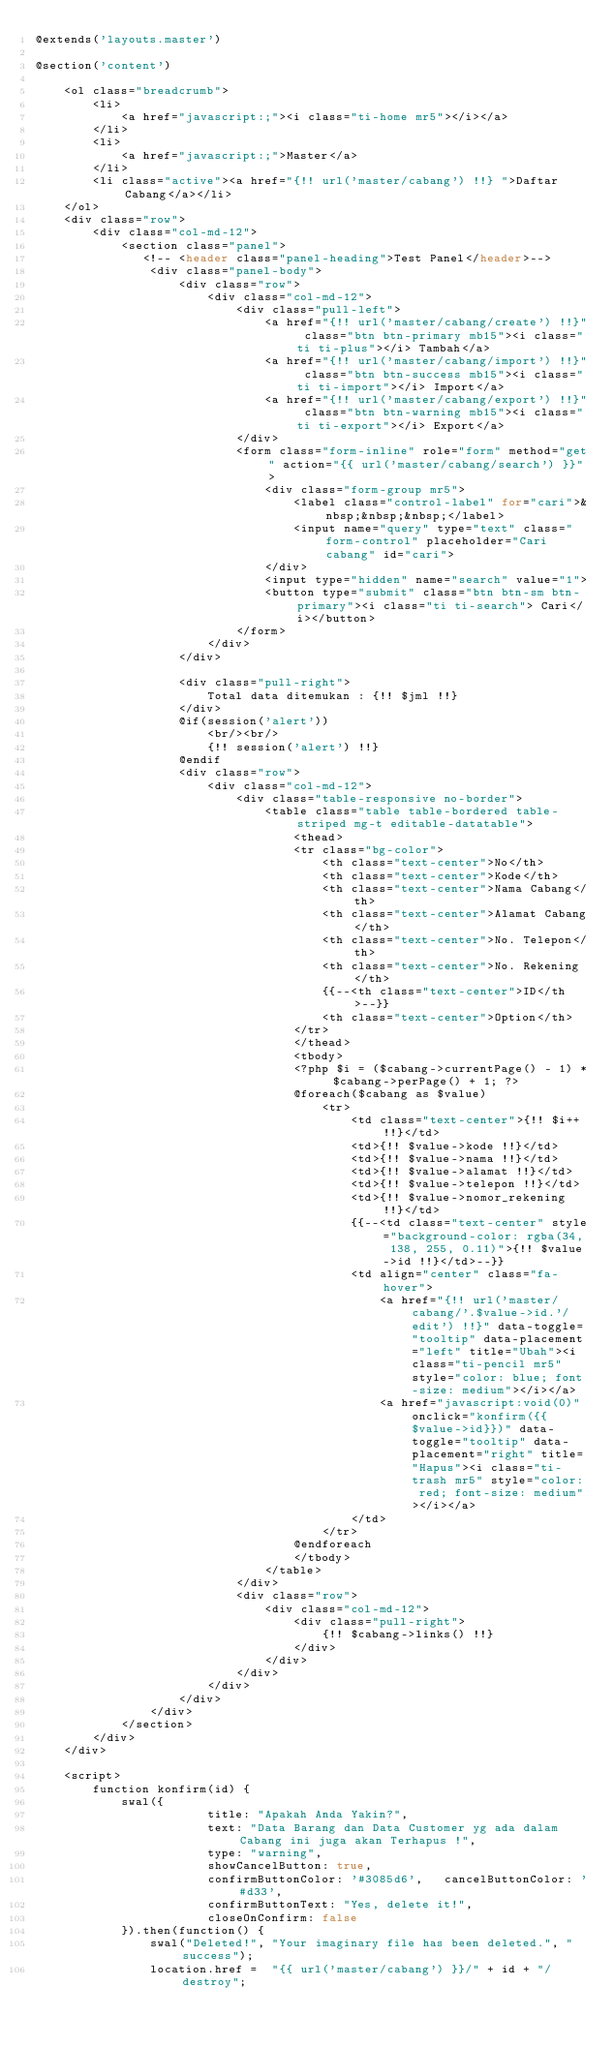Convert code to text. <code><loc_0><loc_0><loc_500><loc_500><_PHP_>@extends('layouts.master')

@section('content')

    <ol class="breadcrumb">
        <li>
            <a href="javascript:;"><i class="ti-home mr5"></i></a>
        </li>
        <li>
            <a href="javascript:;">Master</a>
        </li>
        <li class="active"><a href="{!! url('master/cabang') !!} ">Daftar Cabang</a></li>
    </ol>
    <div class="row">
        <div class="col-md-12">
            <section class="panel">
               <!-- <header class="panel-heading">Test Panel</header>-->
                <div class="panel-body">
                    <div class="row">
                        <div class="col-md-12">
                            <div class="pull-left">
                                <a href="{!! url('master/cabang/create') !!}" class="btn btn-primary mb15"><i class="ti ti-plus"></i> Tambah</a>
                                <a href="{!! url('master/cabang/import') !!}" class="btn btn-success mb15"><i class="ti ti-import"></i> Import</a>
                                <a href="{!! url('master/cabang/export') !!}" class="btn btn-warning mb15"><i class="ti ti-export"></i> Export</a>
                            </div>
                            <form class="form-inline" role="form" method="get" action="{{ url('master/cabang/search') }}">
                                <div class="form-group mr5">
                                    <label class="control-label" for="cari">&nbsp;&nbsp;&nbsp;</label>
                                    <input name="query" type="text" class="form-control" placeholder="Cari cabang" id="cari">
                                </div>
                                <input type="hidden" name="search" value="1">
                                <button type="submit" class="btn btn-sm btn-primary"><i class="ti ti-search"> Cari</i></button>
                            </form>
                        </div>
                    </div>

                    <div class="pull-right">
                        Total data ditemukan : {!! $jml !!}
                    </div>
                    @if(session('alert'))
                        <br/><br/>
                        {!! session('alert') !!}
                    @endif
                    <div class="row">
                        <div class="col-md-12">
                            <div class="table-responsive no-border">
                                <table class="table table-bordered table-striped mg-t editable-datatable">
                                    <thead>
                                    <tr class="bg-color">
                                        <th class="text-center">No</th>
                                        <th class="text-center">Kode</th>
                                        <th class="text-center">Nama Cabang</th>
                                        <th class="text-center">Alamat Cabang</th>
                                        <th class="text-center">No. Telepon</th>
                                        <th class="text-center">No. Rekening</th>
                                        {{--<th class="text-center">ID</th>--}}
                                        <th class="text-center">Option</th>
                                    </tr>
                                    </thead>
                                    <tbody>
                                    <?php $i = ($cabang->currentPage() - 1) * $cabang->perPage() + 1; ?>
                                    @foreach($cabang as $value)
                                        <tr>
                                            <td class="text-center">{!! $i++ !!}</td>
                                            <td>{!! $value->kode !!}</td>
                                            <td>{!! $value->nama !!}</td>
                                            <td>{!! $value->alamat !!}</td>
                                            <td>{!! $value->telepon !!}</td>
                                            <td>{!! $value->nomor_rekening !!}</td>
                                            {{--<td class="text-center" style="background-color: rgba(34, 138, 255, 0.11)">{!! $value->id !!}</td>--}}
                                            <td align="center" class="fa-hover">
                                                <a href="{!! url('master/cabang/'.$value->id.'/edit') !!}" data-toggle="tooltip" data-placement="left" title="Ubah"><i class="ti-pencil mr5" style="color: blue; font-size: medium"></i></a>
                                                <a href="javascript:void(0)" onclick="konfirm({{$value->id}})" data-toggle="tooltip" data-placement="right" title="Hapus"><i class="ti-trash mr5" style="color: red; font-size: medium"></i></a>
                                            </td>
                                        </tr>
                                    @endforeach
                                    </tbody>
                                </table>
                            </div>
                            <div class="row">
                                <div class="col-md-12">
                                    <div class="pull-right">
                                        {!! $cabang->links() !!}
                                    </div>
                                </div>
                            </div>
                        </div>
                    </div>
                </div>
            </section>
        </div>
    </div>

    <script>
        function konfirm(id) {
            swal({
                        title: "Apakah Anda Yakin?",
                        text: "Data Barang dan Data Customer yg ada dalam Cabang ini juga akan Terhapus !",
                        type: "warning",
                        showCancelButton: true,
                        confirmButtonColor: '#3085d6',   cancelButtonColor: '#d33',
                        confirmButtonText: "Yes, delete it!",
                        closeOnConfirm: false
            }).then(function() {
                swal("Deleted!", "Your imaginary file has been deleted.", "success");
                location.href =  "{{ url('master/cabang') }}/" + id + "/destroy";</code> 